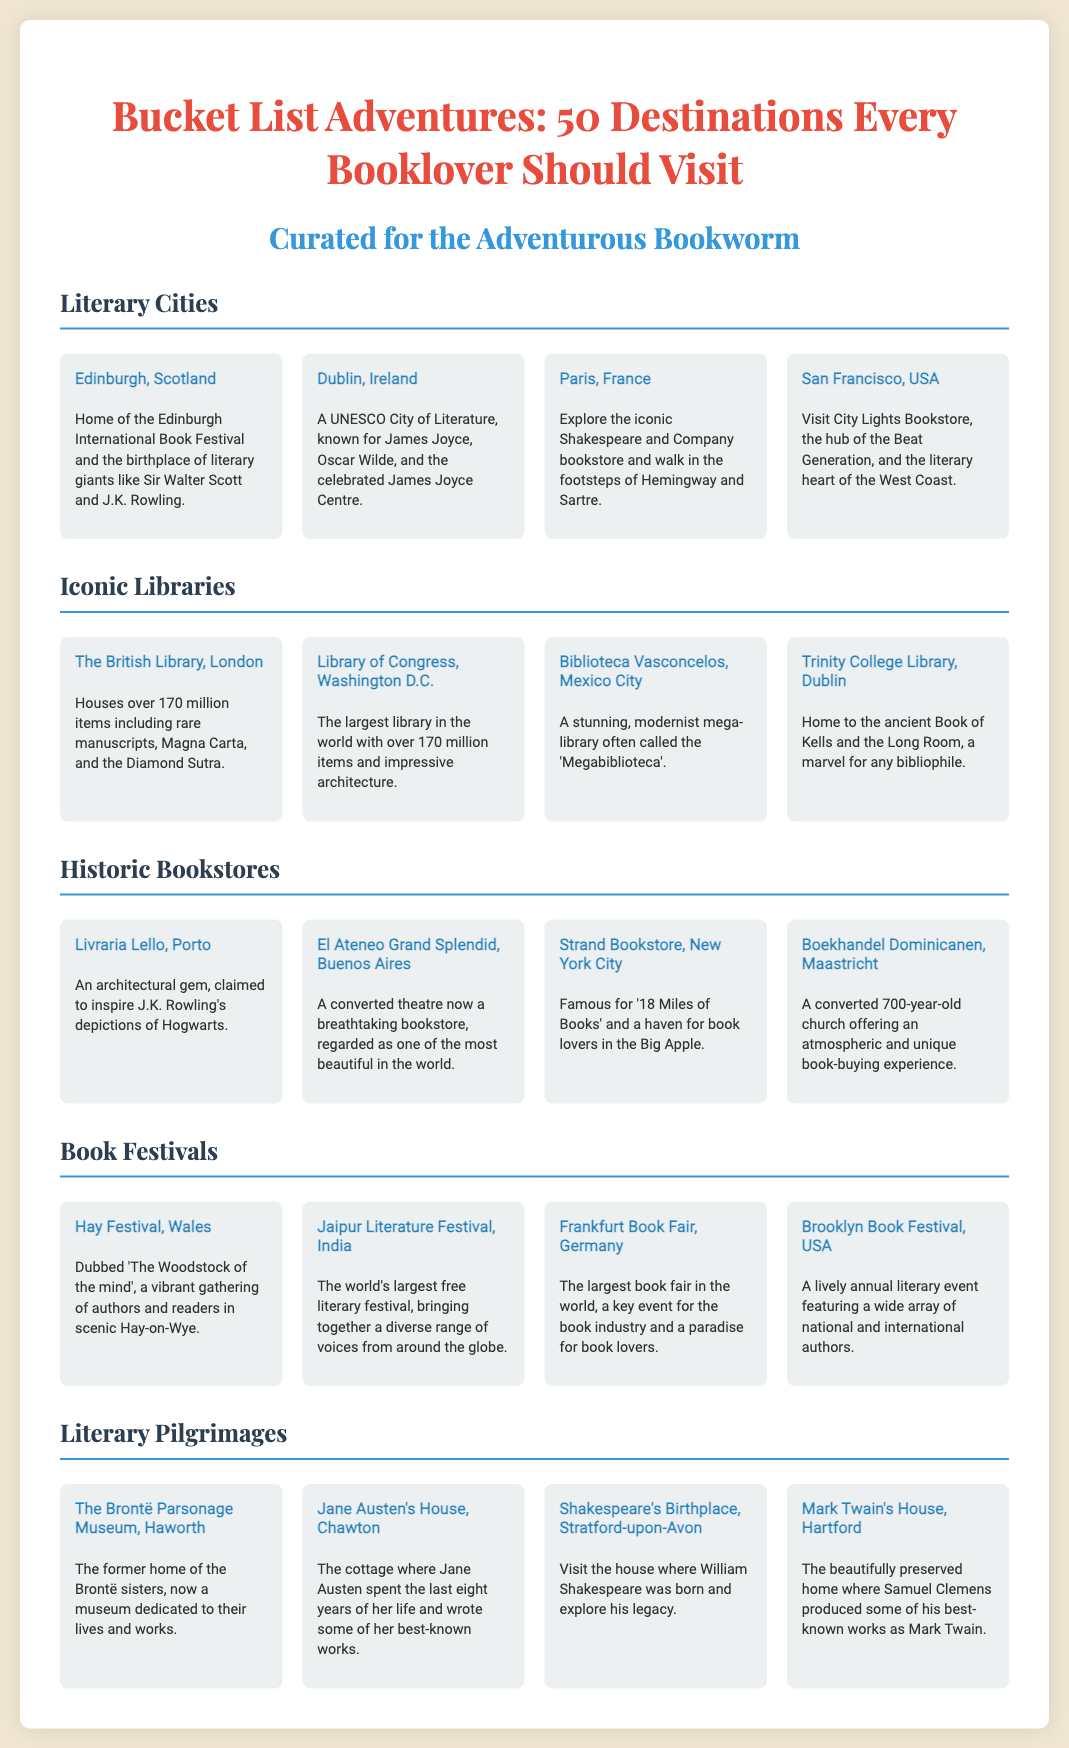what is the title of the poster? The title of the poster is prominently displayed at the top of the document.
Answer: Bucket List Adventures: 50 Destinations Every Booklover Should Visit how many iconic libraries are mentioned? The document lists the number of iconic libraries in the "Iconic Libraries" section.
Answer: Four what city is known for the Edinburgh International Book Festival? The specific city where this festival takes place is mentioned in the "Literary Cities" section.
Answer: Edinburgh what type of event is the Jaipur Literature Festival? The nature and significance of this festival is described in the "Book Festivals" section.
Answer: Free literary festival which bookstore is referred to as an architectural gem in Porto? This information is provided in the "Historic Bookstores" section.
Answer: Livraria Lello name one of the literary pilgrimages mentioned. The document lists several locations under "Literary Pilgrimages."
Answer: The Brontë Parsonage Museum which city is the largest library in the world located? The document specifies the location of this library in the "Iconic Libraries" section.
Answer: Washington D.C what is the main theme of the poster? The overarching topic of the document is summarized in the title and introduction.
Answer: Adventures for booklovers 